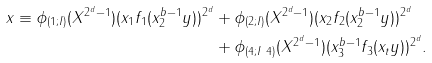<formula> <loc_0><loc_0><loc_500><loc_500>x \equiv \phi _ { ( 1 ; I ) } ( X ^ { 2 ^ { d } - 1 } ) ( x _ { 1 } f _ { 1 } ( x _ { 2 } ^ { b - 1 } y ) ) ^ { 2 ^ { d } } & + \phi _ { ( 2 ; I ) } ( X ^ { 2 ^ { d } - 1 } ) ( x _ { 2 } f _ { 2 } ( x _ { 2 } ^ { b - 1 } y ) ) ^ { 2 ^ { d } } \\ & + \phi _ { ( 4 ; I \ 4 ) } ( X ^ { 2 ^ { d } - 1 } ) ( x _ { 3 } ^ { b - 1 } f _ { 3 } ( x _ { t } y ) ) ^ { 2 ^ { d } } .</formula> 